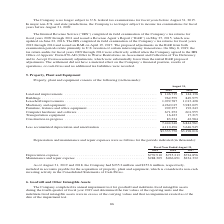According to Jabil Circuit's financial document, What were the land and improvements in 2019? According to the financial document, $146,719 (in thousands). The relevant text states: "Land and improvements . $ 146,719 $ 144,136 Buildings . 962,559 849,975 Leasehold improvements . 1,092,787 1,013,428 Machinery and eq..." Also, What was the value of buildings in 2018? According to the financial document, 849,975 (in thousands). The relevant text states: "vements . $ 146,719 $ 144,136 Buildings . 962,559 849,975 Leasehold improvements . 1,092,787 1,013,428 Machinery and equipment . 4,262,015 3,983,025 Furnitur..." Also, Which years does the table provide information for Property, plant and equipment? The document shows two values: 2019 and 2018. From the document: "2019 2018 2019 2018..." Also, In 2019, how many property, plant and equipment exceeded $1,000,000 thousand? Counting the relevant items in the document: Machinery and equipment, Leasehold improvements, I find 2 instances. The key data points involved are: Leasehold improvements, Machinery and equipment. Also, can you calculate: What was the change in the amount of land and improvements between 2018 and 2019? Based on the calculation: $146,719-$144,136, the result is 2583 (in thousands). This is based on the information: "Land and improvements . $ 146,719 $ 144,136 Buildings . 962,559 849,975 Leasehold improvements . 1,092,787 1,013,428 Machinery and equipment . Land and improvements . $ 146,719 $ 144,136 Buildings . 9..." The key data points involved are: 144,136, 146,719. Also, can you calculate: What was the percentage change in total property, plant and equipment between 2018 and 2019? To answer this question, I need to perform calculations using the financial data. The calculation is: ($3,333,750-$3,198,016)/$3,198,016, which equals 4.24 (percentage). This is based on the information: "$3,333,750 $3,198,016 $3,333,750 $3,198,016..." The key data points involved are: 3,198,016, 3,333,750. 